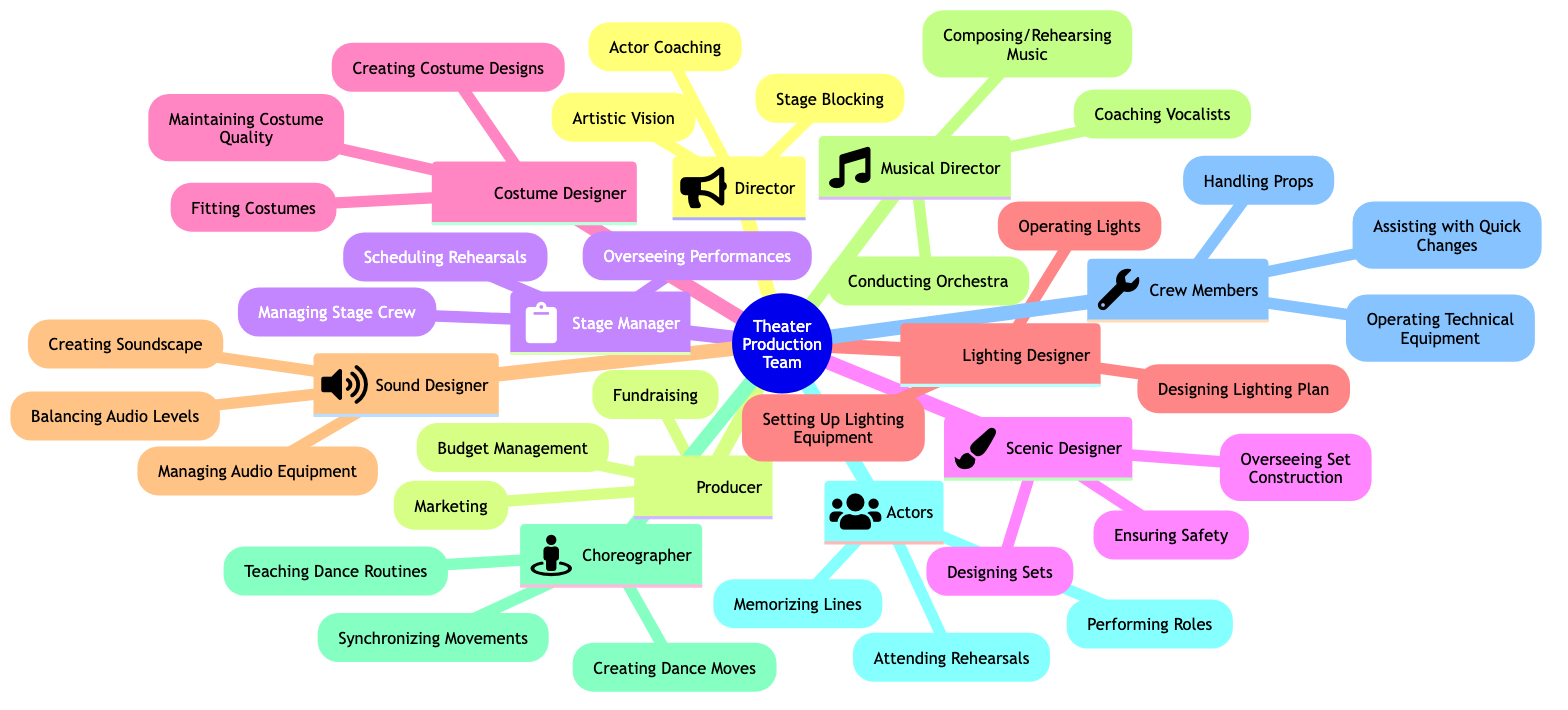What are the three responsibilities of the Director? According to the diagram, the responsibilities listed under the Director node include Artistic Vision, Actor Coaching, and Stage Blocking.
Answer: Artistic Vision, Actor Coaching, Stage Blocking How many collaborators does the Producer have? The Producer collaborates with three roles: Director, Stage Manager, and Costume Designer, as stated in the node.
Answer: 3 Who collaborates with the Stage Manager? The diagram specifies that the Stage Manager collaborates with the Director, Actors, and Crew Members. Therefore, the answer is those three.
Answer: Director, Actors, Crew Members What is one responsibility of the Scenic Designer? The node for the Scenic Designer shows three responsibilities: Designing Sets, Overseeing Set Construction, and Ensuring Safety. Any of these can be stated, but let's pick one.
Answer: Designing Sets Which two roles collaborate with the Musical Director? From the diagram data, the Musical Director collaborates with the Director and Choreographer, in addition to the Sound Designer, but we only need two for this question.
Answer: Director, Choreographer Which role is involved in creating dance moves? The Choreographer node outlines various responsibilities, with creating dance moves specifically listed as one of them.
Answer: Choreographer What is the key responsibility of the Sound Designer? The diagram highlights three main responsibilities of the Sound Designer, but if we focus on one key aspect, it is creating soundscape which is unique to this role.
Answer: Creating Soundscape What type of designer is responsible for fitting costumes? The responsibilities listed for the Costume Designer include Fitting Costumes, which makes them directly responsible for this activity as per the node details.
Answer: Costume Designer How many responsibilities does the Crew Members have? The Crew Members node outlines three clear responsibilities: Handling Props, Assisting with Quick Changes, and Operating Technical Equipment. Thus, there are three.
Answer: 3 